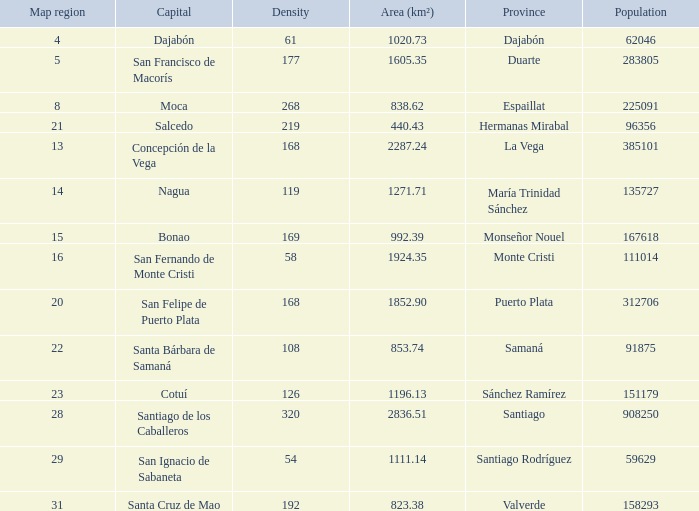How many capitals are there when area (km²) is 1111.14? 1.0. 